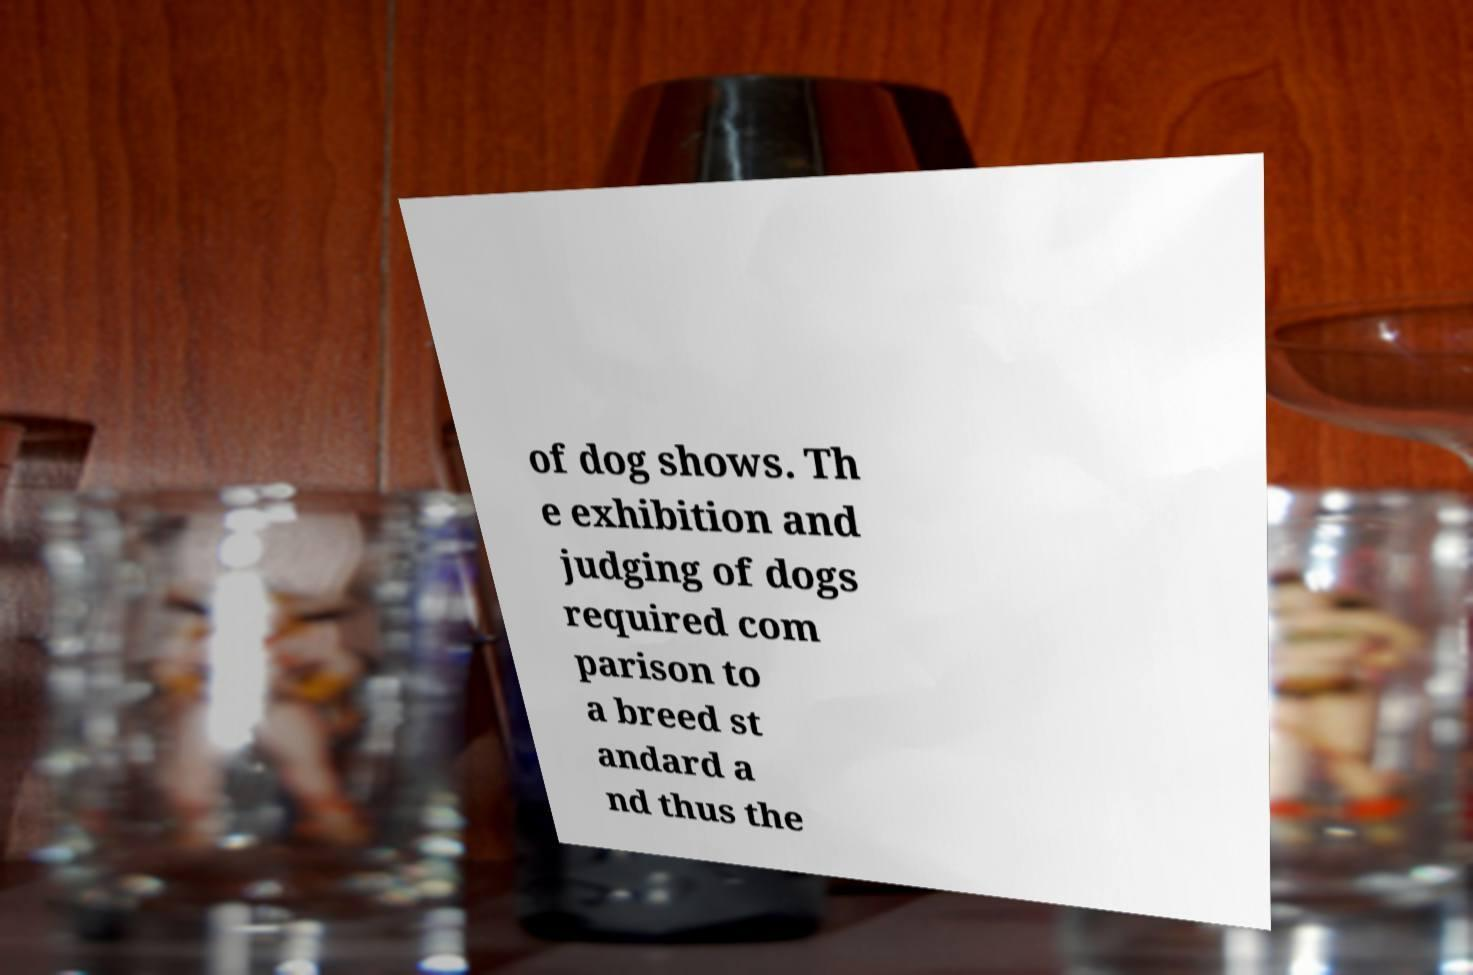I need the written content from this picture converted into text. Can you do that? of dog shows. Th e exhibition and judging of dogs required com parison to a breed st andard a nd thus the 